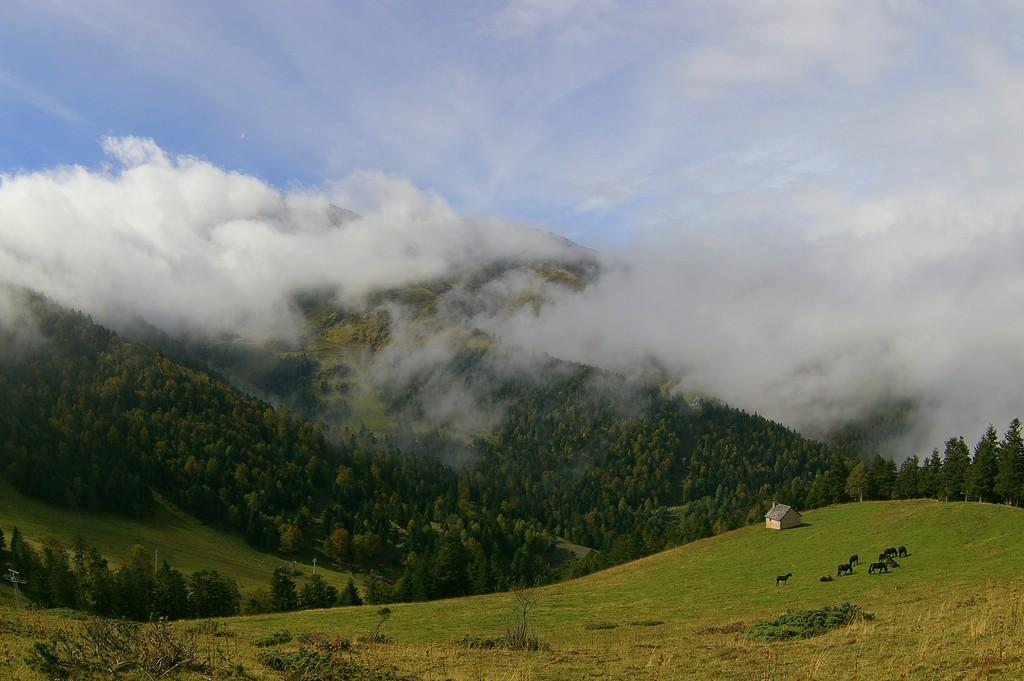What type of landscape feature is in the image? There is a hill in the image. What type of structure is in the image? There is a small house in the image. What type of living organisms are in the image? Animals are present in the image. What is the source of the smoke visible in the image? The source of the smoke is not specified in the image. What part of the natural environment is visible in the image? The sky and trees are visible in the image. What type of chess piece can be seen on the hill in the image? There is no chess piece visible on the hill in the image. What type of dog is present in the image? There is no dog present in the image. 